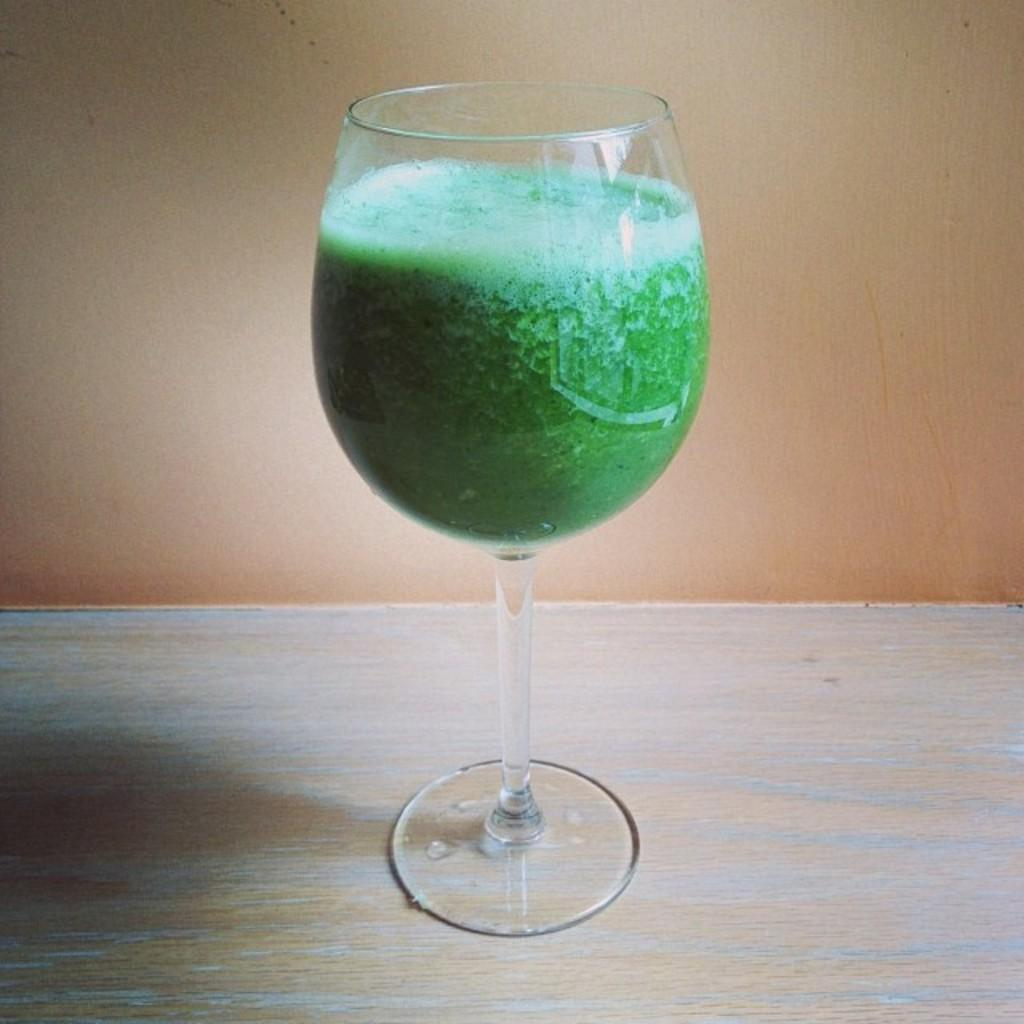What is in the wine glass that is visible in the image? The wine glass is filled with green color liquid. Where is the wine glass located in the image? The wine glass is placed on a table. What type of notebook is being used to make a wish in the image? There is no notebook or wish-making activity present in the image. The image only features a wine glass filled with green liquid and placed on a table. 